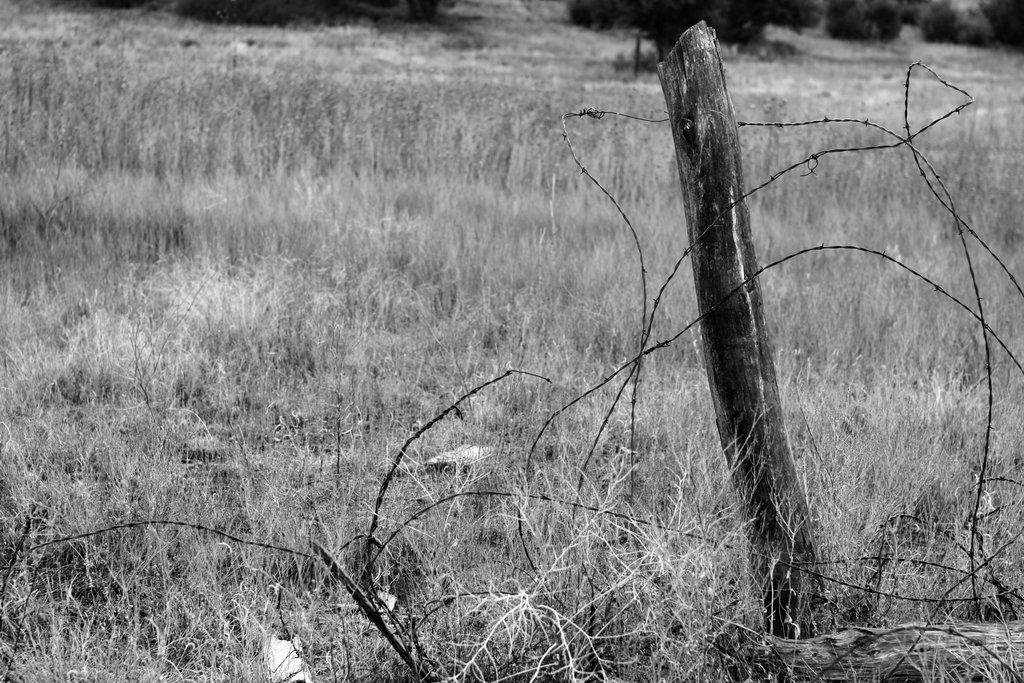What is the color scheme of the image? The image is black and white. What type of vegetation can be seen in the image? There is dried grass in the image. What object made of wood is present in the image? There is a wooden stick in the image. What type of man-made structure can be seen in the image? There is a fence wire in the image. Where is the jewel hidden in the image? There is no jewel present in the image. What type of yard can be seen in the image? The image does not show a yard; it only contains dried grass, a wooden stick, and a fence wire. 